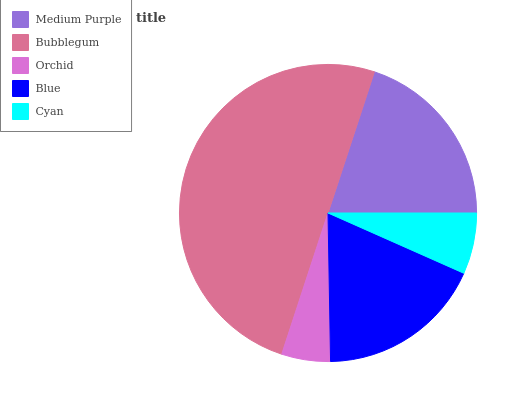Is Orchid the minimum?
Answer yes or no. Yes. Is Bubblegum the maximum?
Answer yes or no. Yes. Is Bubblegum the minimum?
Answer yes or no. No. Is Orchid the maximum?
Answer yes or no. No. Is Bubblegum greater than Orchid?
Answer yes or no. Yes. Is Orchid less than Bubblegum?
Answer yes or no. Yes. Is Orchid greater than Bubblegum?
Answer yes or no. No. Is Bubblegum less than Orchid?
Answer yes or no. No. Is Blue the high median?
Answer yes or no. Yes. Is Blue the low median?
Answer yes or no. Yes. Is Orchid the high median?
Answer yes or no. No. Is Orchid the low median?
Answer yes or no. No. 